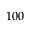Convert formula to latex. <formula><loc_0><loc_0><loc_500><loc_500>1 0 0</formula> 